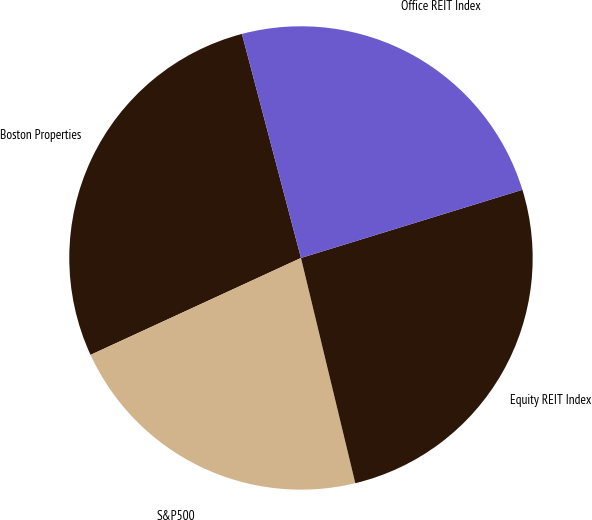<chart> <loc_0><loc_0><loc_500><loc_500><pie_chart><fcel>Boston Properties<fcel>S&P500<fcel>Equity REIT Index<fcel>Office REIT Index<nl><fcel>27.77%<fcel>21.9%<fcel>25.99%<fcel>24.35%<nl></chart> 